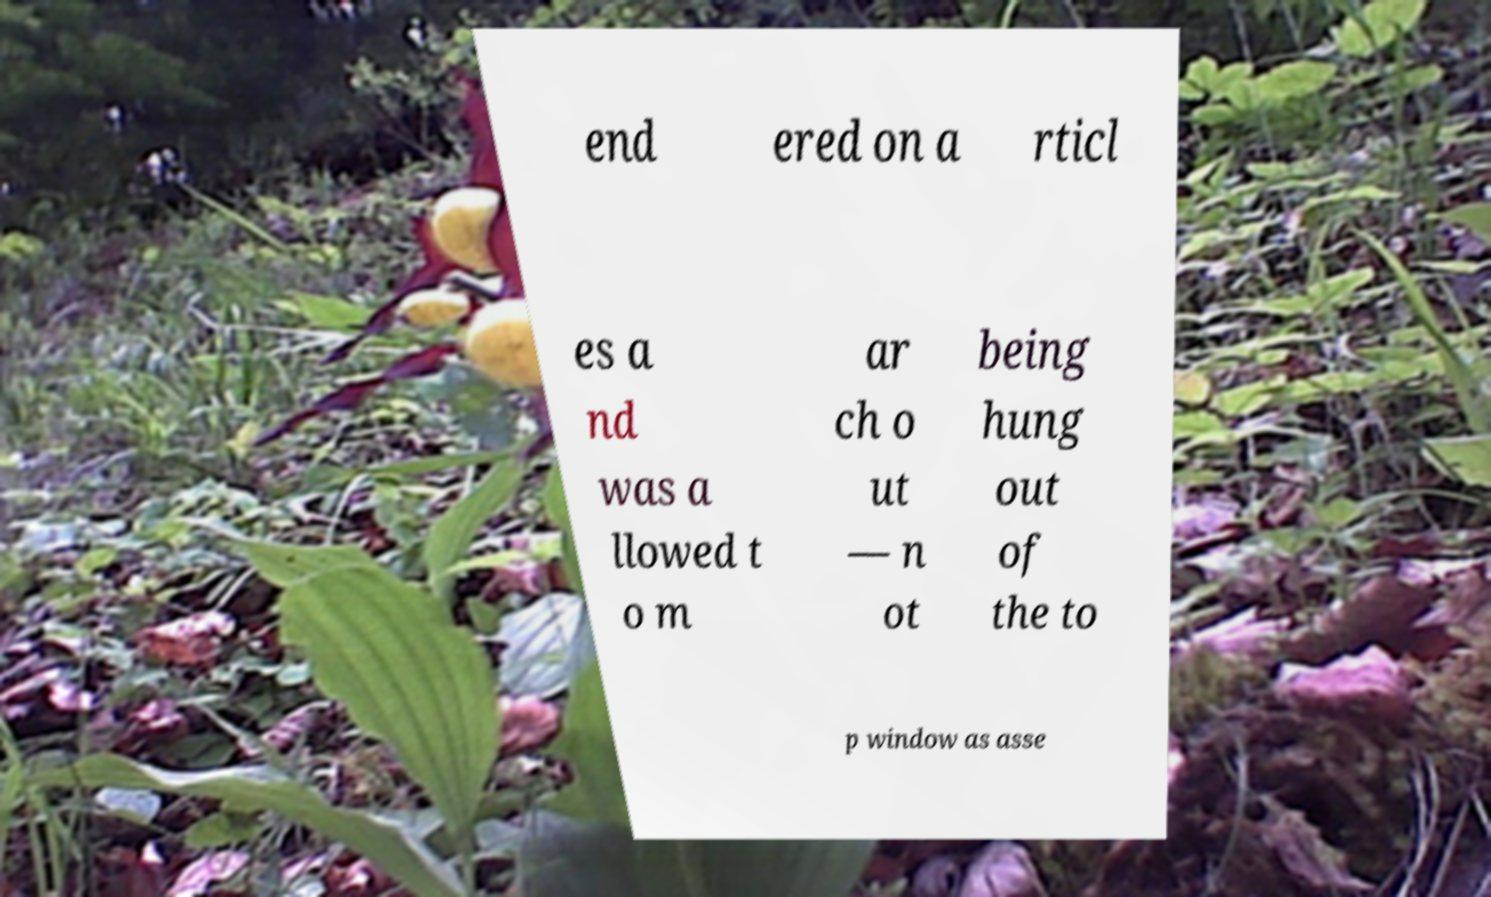What messages or text are displayed in this image? I need them in a readable, typed format. end ered on a rticl es a nd was a llowed t o m ar ch o ut — n ot being hung out of the to p window as asse 